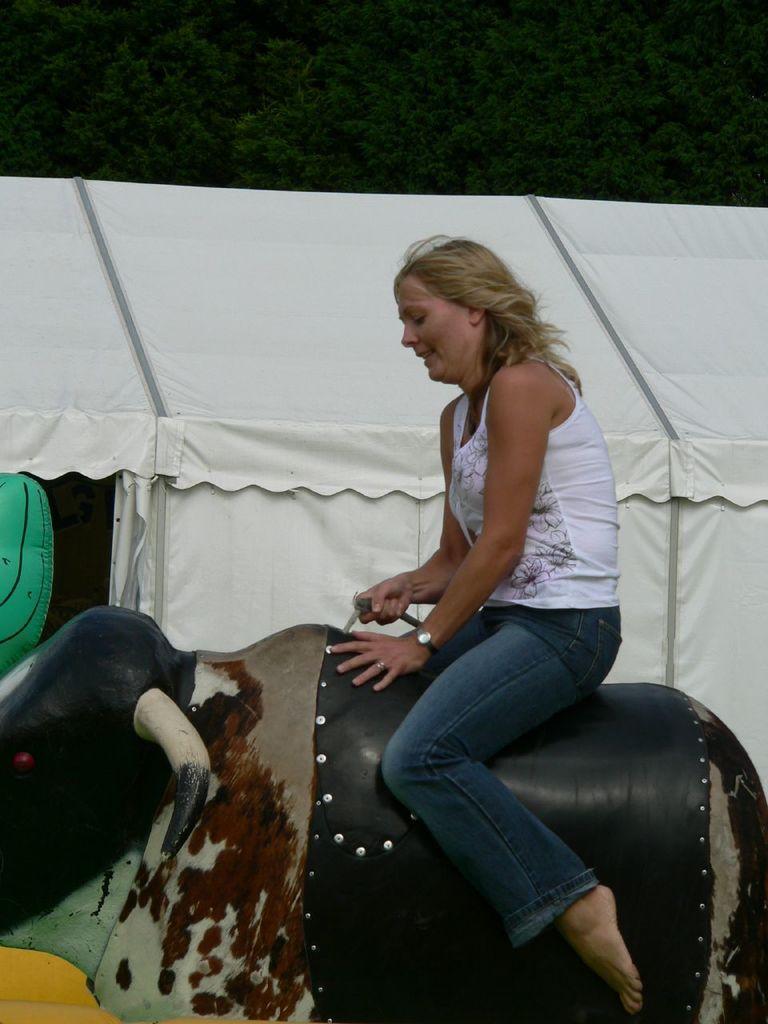Please provide a concise description of this image. In this image I can see a woman sitting on a toy animal facing towards the left side and she is holding an object in the hand. In the background there is a tent. At the top of the image there are many trees. 